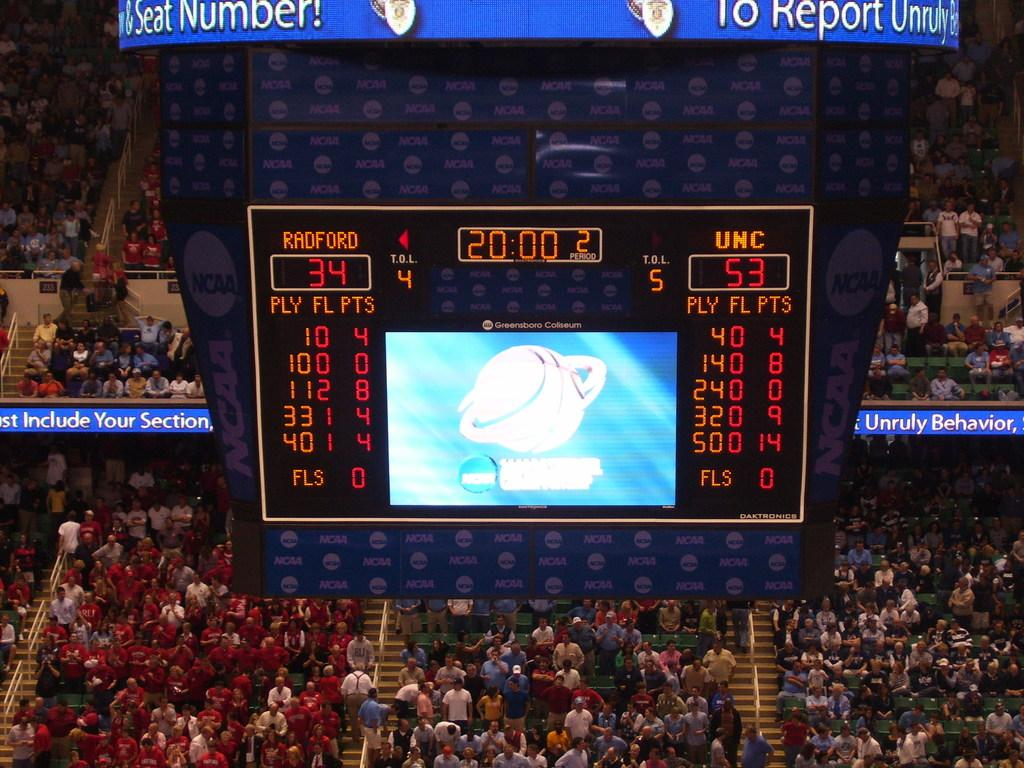<image>
Summarize the visual content of the image. the number 53 is shown in red on the scoreboard 